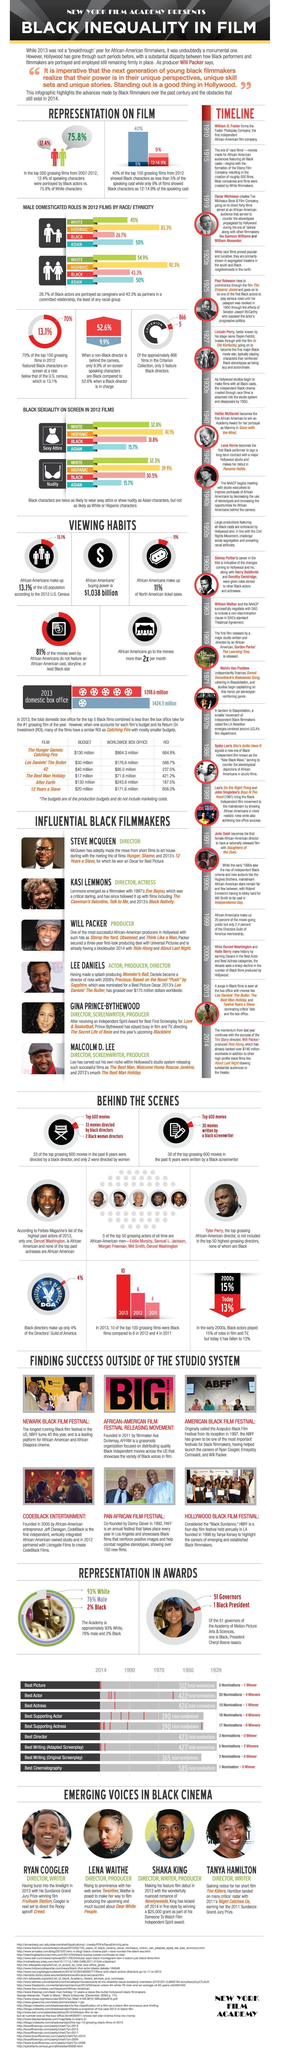In which year was Daughters of Dust released?
Answer the question with a short phrase. 1991 What percent of Hispanic actors are shown as committed partners? 92.3% How many of the characters are black when a black director makes a movie? 52.6% In which year was the Foster Photoplay company formed? 1910 